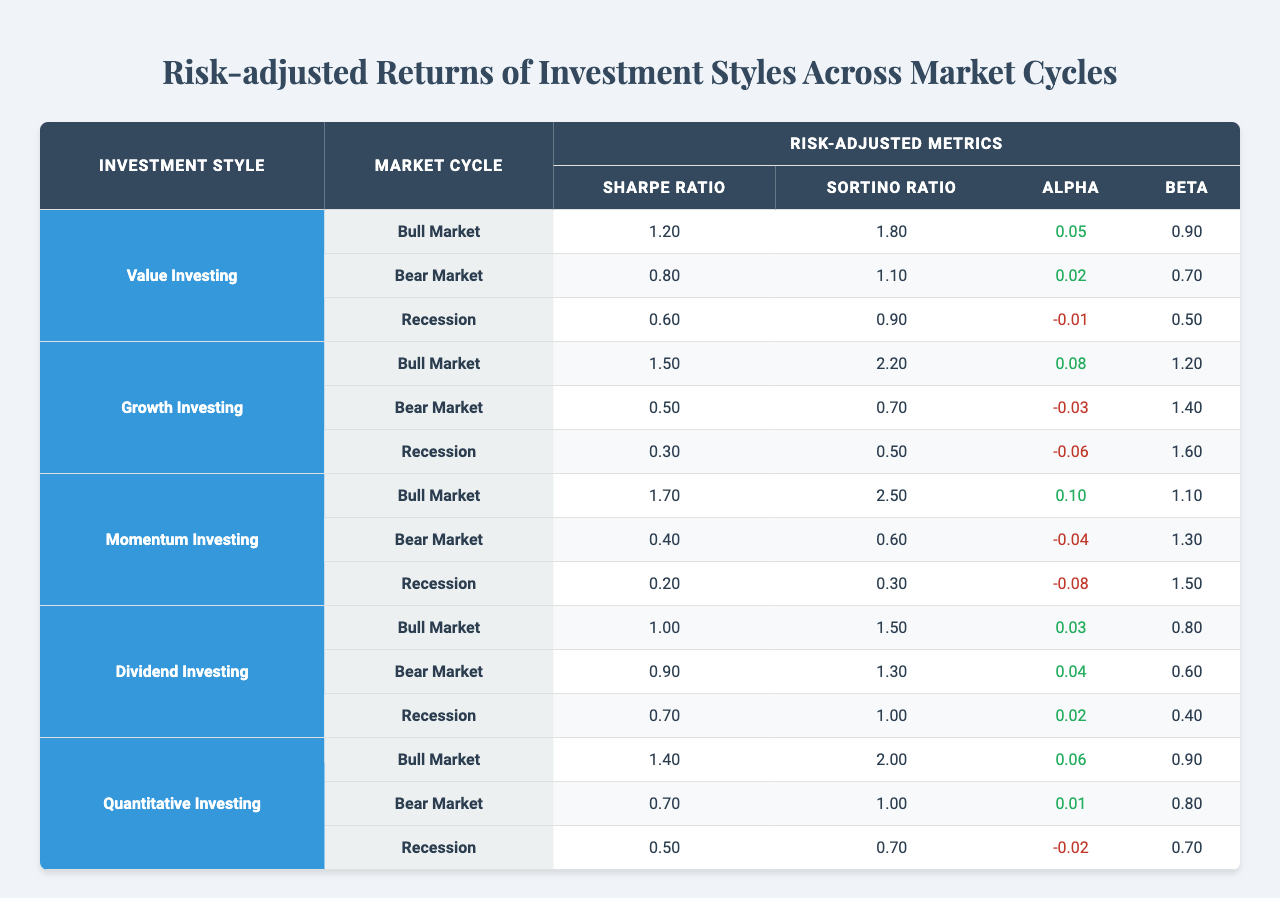What is the Sharpe Ratio for Value Investing during a Bull Market? The Sharpe Ratio for Value Investing in a Bull Market is stated in the table as 1.2.
Answer: 1.2 What is the highest Sortino Ratio among all investment styles in a Bear Market? The Sortino Ratios for Bear Markets are 1.1 (Value), 0.7 (Growth), 0.6 (Momentum), 1.3 (Dividend), and 1.0 (Quantitative). The highest value is 1.3 from Dividend Investing.
Answer: 1.3 Does Growth Investing achieve a positive Alpha during any market cycle? In the table, Growth Investing shows negative Alpha values (-0.03 in Bear Market and -0.06 in Recession) but has a positive Alpha of 0.08 in the Bull Market. Therefore, yes, it does achieve positive Alpha during the Bull Market.
Answer: Yes Which investment style has the lowest Sharpe Ratio during a Recession? Examining the Recession data, the Sharpe Ratios are 0.6 (Value), 0.3 (Growth), 0.2 (Momentum), 0.7 (Dividend), and 0.5 (Quantitative). Momentum Investing has the lowest value at 0.2.
Answer: 0.2 What is the average Sortino Ratio for Dividend Investing across all market cycles? The Sortino Ratios for Dividend Investing are 1.5 (Bull Market), 1.3 (Bear Market), and 1.0 (Recession). Adding these gives 1.5 + 1.3 + 1.0 = 3.8. Dividing by 3 gives an average of 3.8 / 3 = 1.27.
Answer: 1.27 Is it true that all investment styles have a higher Sharpe Ratio in Bull Markets compared to Bear Markets? By inspecting the Bull and Bear market metrics, Value (1.2 vs 0.8), Growth (1.5 vs 0.5), Momentum (1.7 vs 0.4), Dividend (1.0 vs 0.9), and Quantitative (1.4 vs 0.7) all confirm higher Sharpe Ratios in Bull Markets, thus the statement is true.
Answer: True Which investment style has the highest Alpha during a Bull Market? Looking at the Bull Market metrics, Value has 0.05, Growth 0.08, Momentum 0.1, Dividend 0.03, and Quantitative 0.06. The highest Alpha is 0.1 from Momentum Investing.
Answer: 0.1 What is the difference in Beta between the worst and best performing investment styles during a Bear Market? The Betas for Bear Markets are 0.7 (Value), 1.4 (Growth), 1.3 (Momentum), 0.6 (Dividend), and 0.8 (Quantitative). The best (Growth: 1.4) minus the worst (Dividend: 0.6) gives 1.4 - 0.6 = 0.8.
Answer: 0.8 What was the Sharpe Ratio for Momentum Investing during a Bull Market? The table indicates the Sharpe Ratio for Momentum Investing during a Bull Market is 1.7.
Answer: 1.7 In which market cycle does Value Investing show the highest risk-adjusted performance based on the Sortino Ratio? The Sortino Ratios for Value Investing are 1.8 (Bull Market), 1.1 (Bear Market), and 0.9 (Recession). The highest is 1.8 during the Bull Market.
Answer: Bull Market 